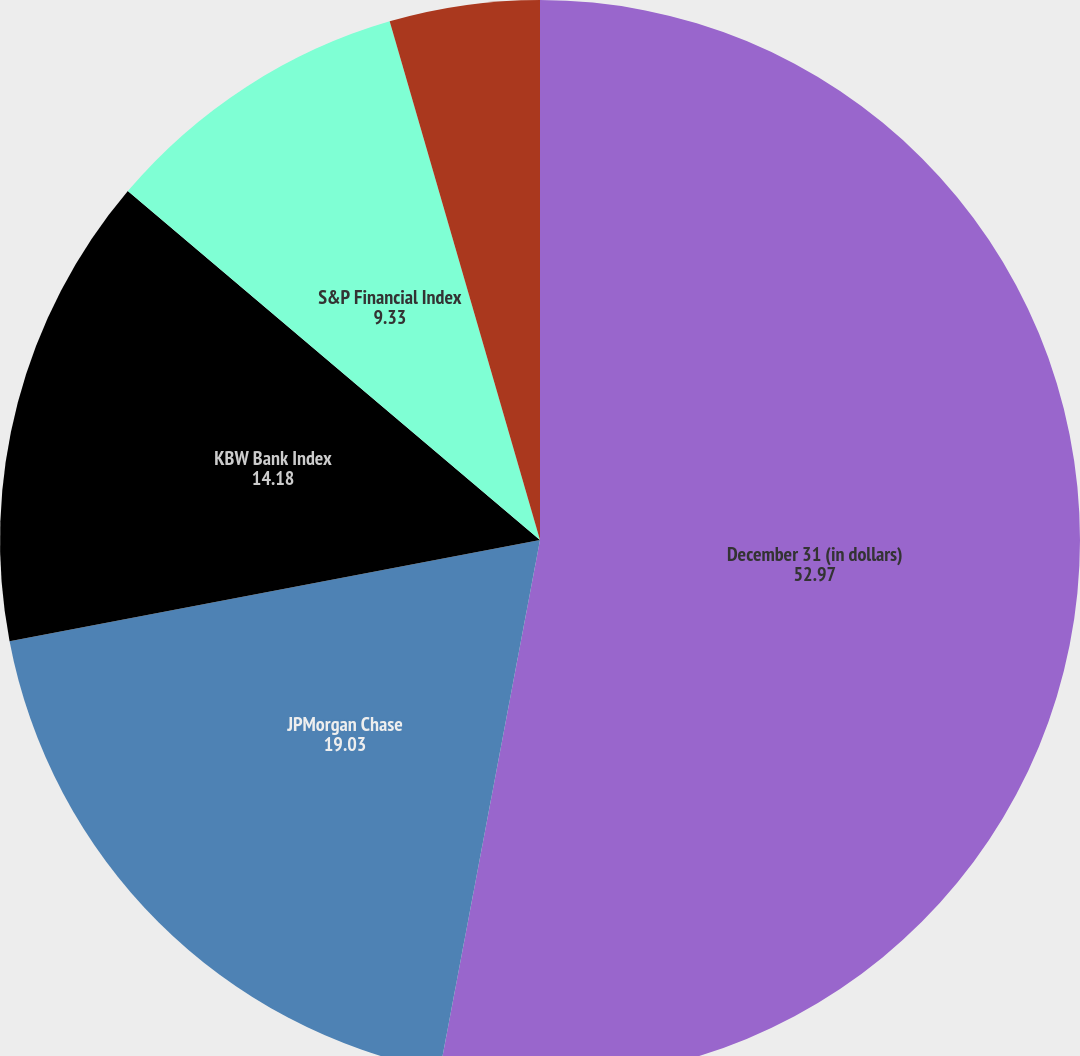<chart> <loc_0><loc_0><loc_500><loc_500><pie_chart><fcel>December 31 (in dollars)<fcel>JPMorgan Chase<fcel>KBW Bank Index<fcel>S&P Financial Index<fcel>S&P 500 Index<nl><fcel>52.97%<fcel>19.03%<fcel>14.18%<fcel>9.33%<fcel>4.49%<nl></chart> 